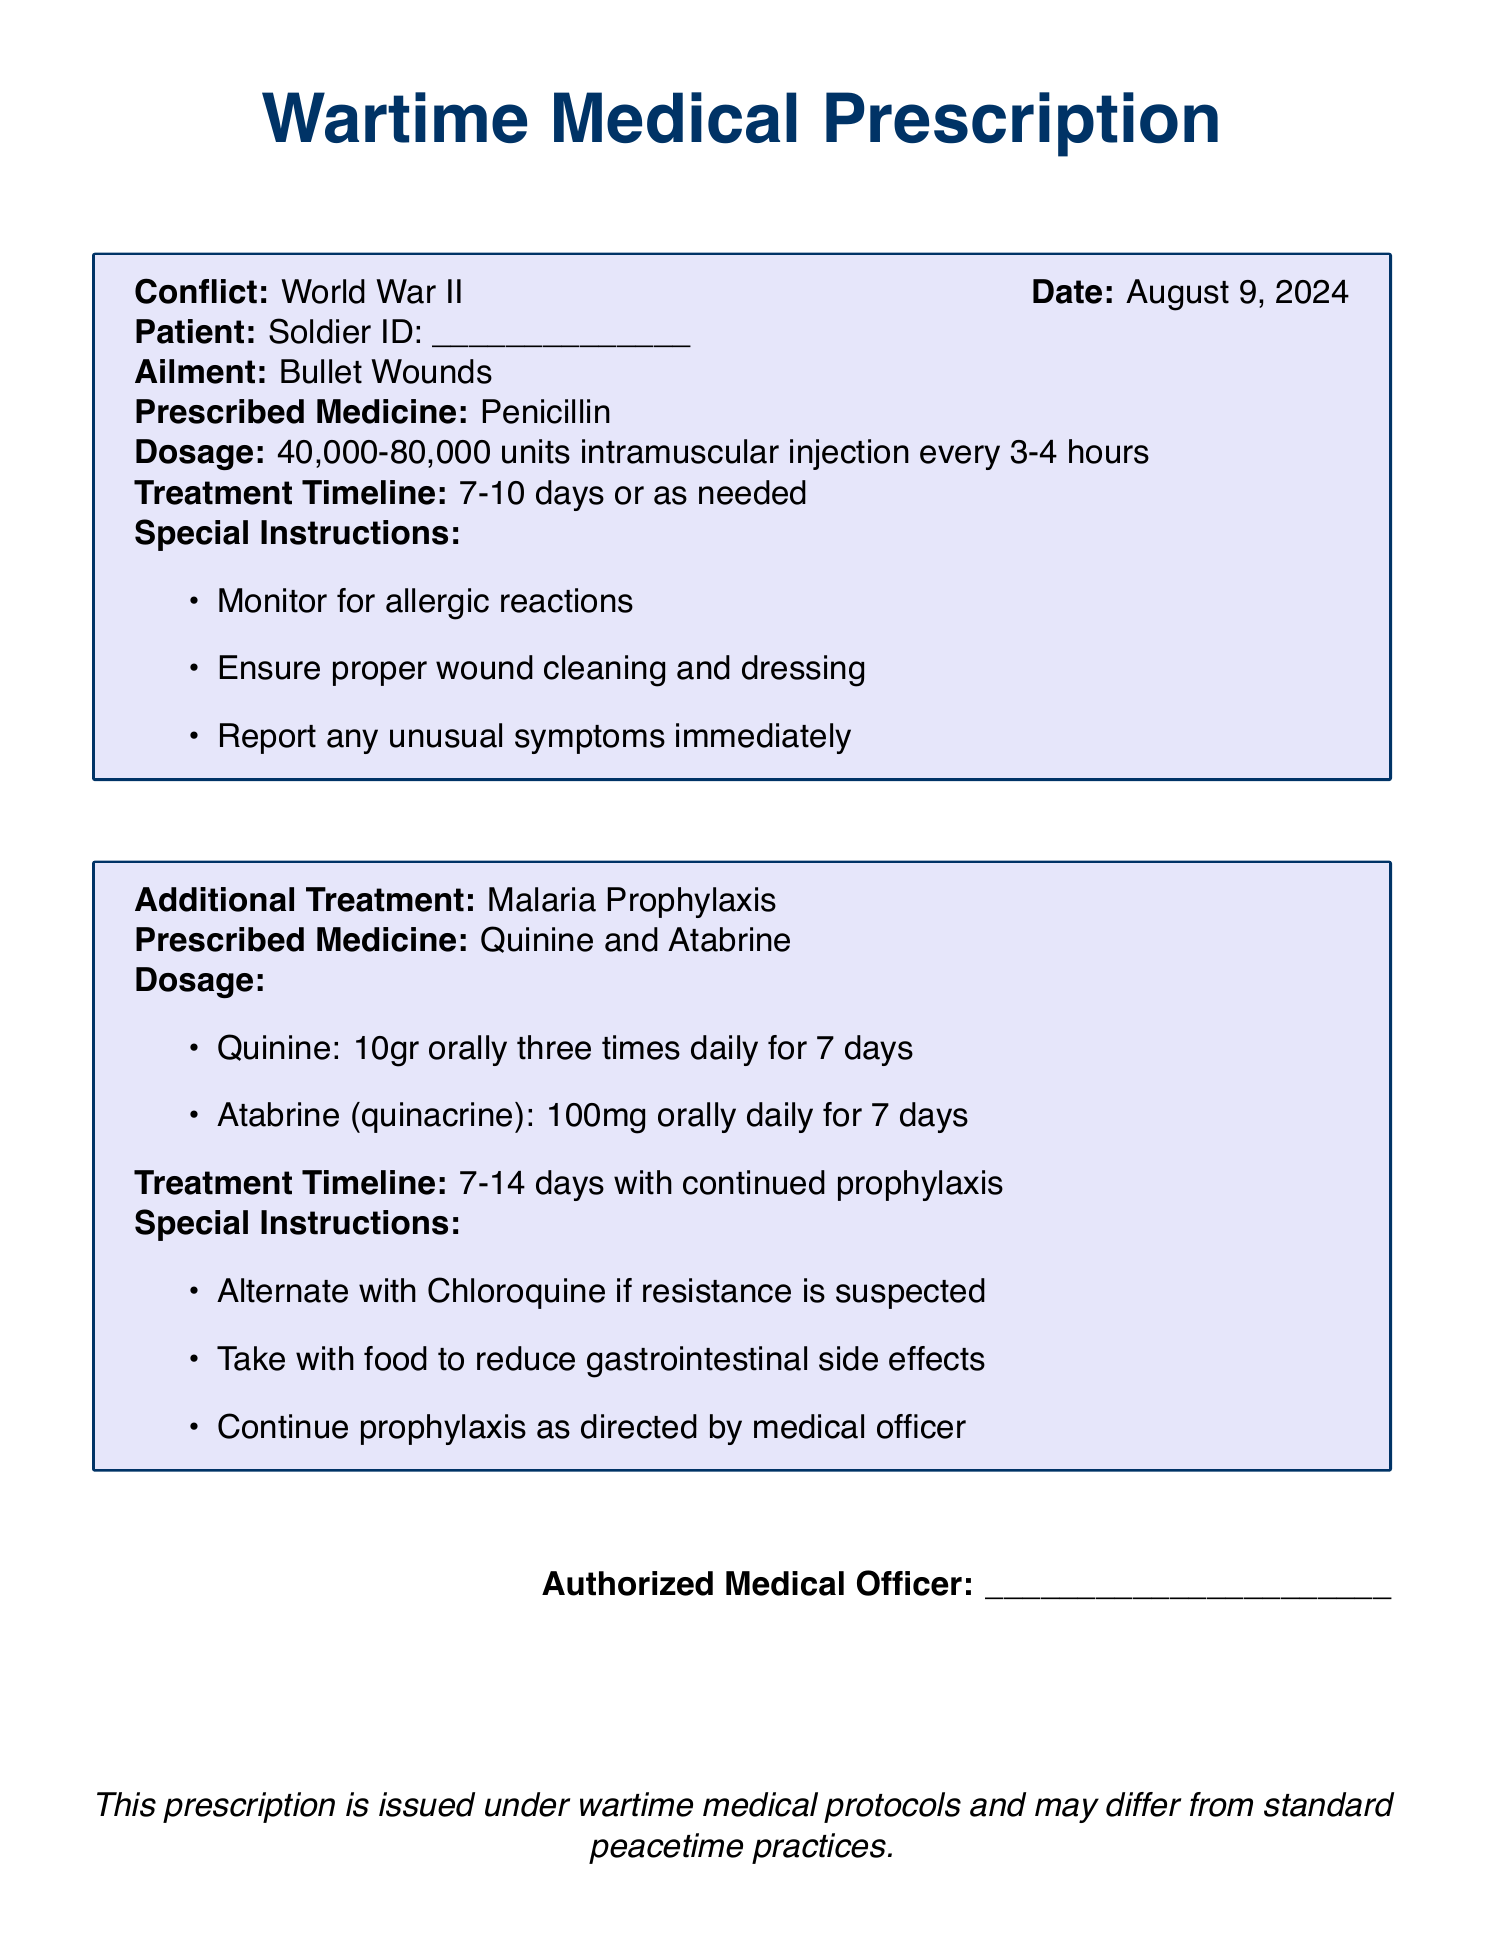What is the document about? The document is a prescription detailing wartime medical practices, specifically for soldiers during conflicts.
Answer: Wartime Medical Prescription What is the ailment mentioned in the prescription? The ailment is specified under the 'Ailment' section of the prescription.
Answer: Bullet Wounds What is the prescribed medicine for bullet wounds? The prescribed medicine is stated in the section that describes treatment for bullet wounds.
Answer: Penicillin What is the dosage of Penicillin? The dosage information is provided in the medicine section under bullet wounds.
Answer: 40,000-80,000 units intramuscular injection every 3-4 hours What is the treatment timeline for bullet wounds? The treatment timeline is indicated in the same section where the ailment and medicine are listed.
Answer: 7-10 days or as needed How often should Quinine be taken? The frequency of Quinine dosage is specified in the additional treatment section for malaria prophylaxis.
Answer: Three times daily For how many days is Atabrine prescribed? The number of days for which Atabrine is prescribed can be found in the malaria prophylaxis section.
Answer: 7 days What are the special instructions for the medicine? Special instructions are listed under each treatment category, pertaining to monitoring and administration.
Answer: Monitor for allergic reactions Who authorized the prescription? The authorized medical officer's name is indicated at the end of the prescription.
Answer: Authorized Medical Officer What does the last line of the document state? The last line of the document provides a statement regarding the nature of the prescription under wartime protocols.
Answer: This prescription is issued under wartime medical protocols and may differ from standard peacetime practices 